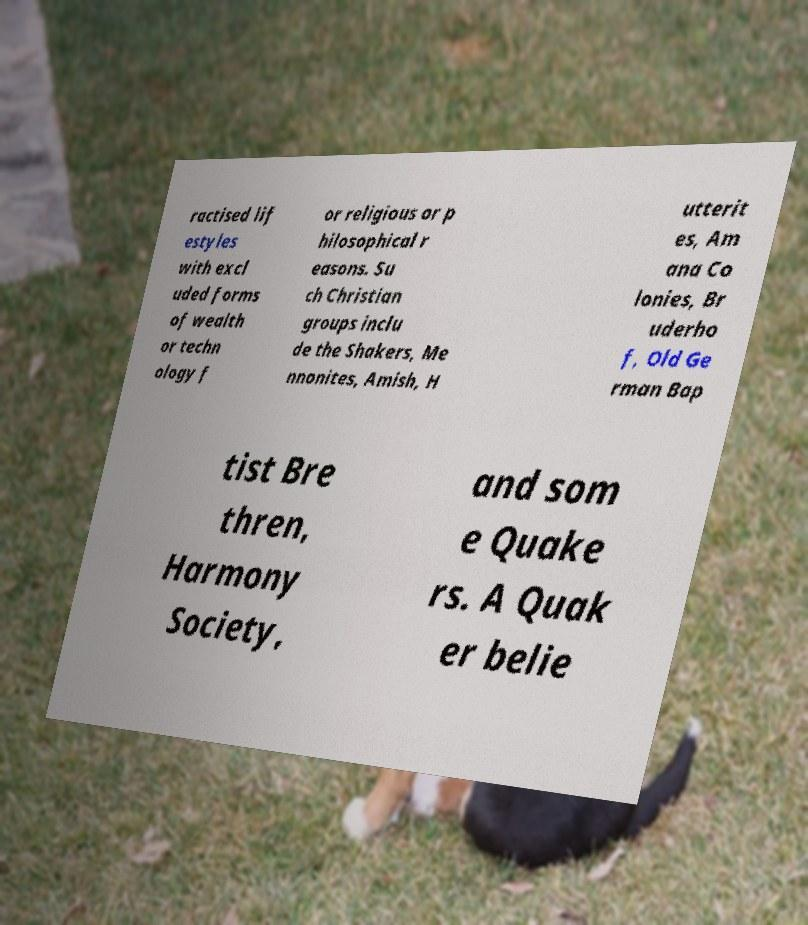I need the written content from this picture converted into text. Can you do that? ractised lif estyles with excl uded forms of wealth or techn ology f or religious or p hilosophical r easons. Su ch Christian groups inclu de the Shakers, Me nnonites, Amish, H utterit es, Am ana Co lonies, Br uderho f, Old Ge rman Bap tist Bre thren, Harmony Society, and som e Quake rs. A Quak er belie 